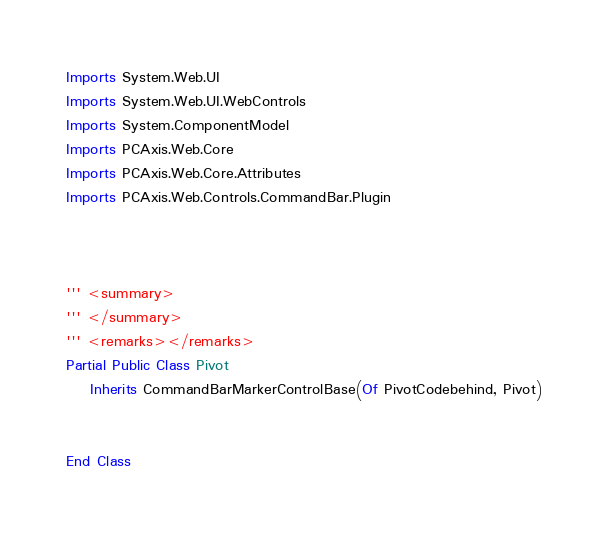<code> <loc_0><loc_0><loc_500><loc_500><_VisualBasic_>Imports System.Web.UI
Imports System.Web.UI.WebControls
Imports System.ComponentModel
Imports PCAxis.Web.Core
Imports PCAxis.Web.Core.Attributes
Imports PCAxis.Web.Controls.CommandBar.Plugin



''' <summary>
''' </summary>
''' <remarks></remarks>
Partial Public Class Pivot
    Inherits CommandBarMarkerControlBase(Of PivotCodebehind, Pivot)


End Class
</code> 